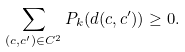<formula> <loc_0><loc_0><loc_500><loc_500>\sum _ { ( c , c ^ { \prime } ) \in C ^ { 2 } } P _ { k } ( d ( c , c ^ { \prime } ) ) \geq 0 .</formula> 